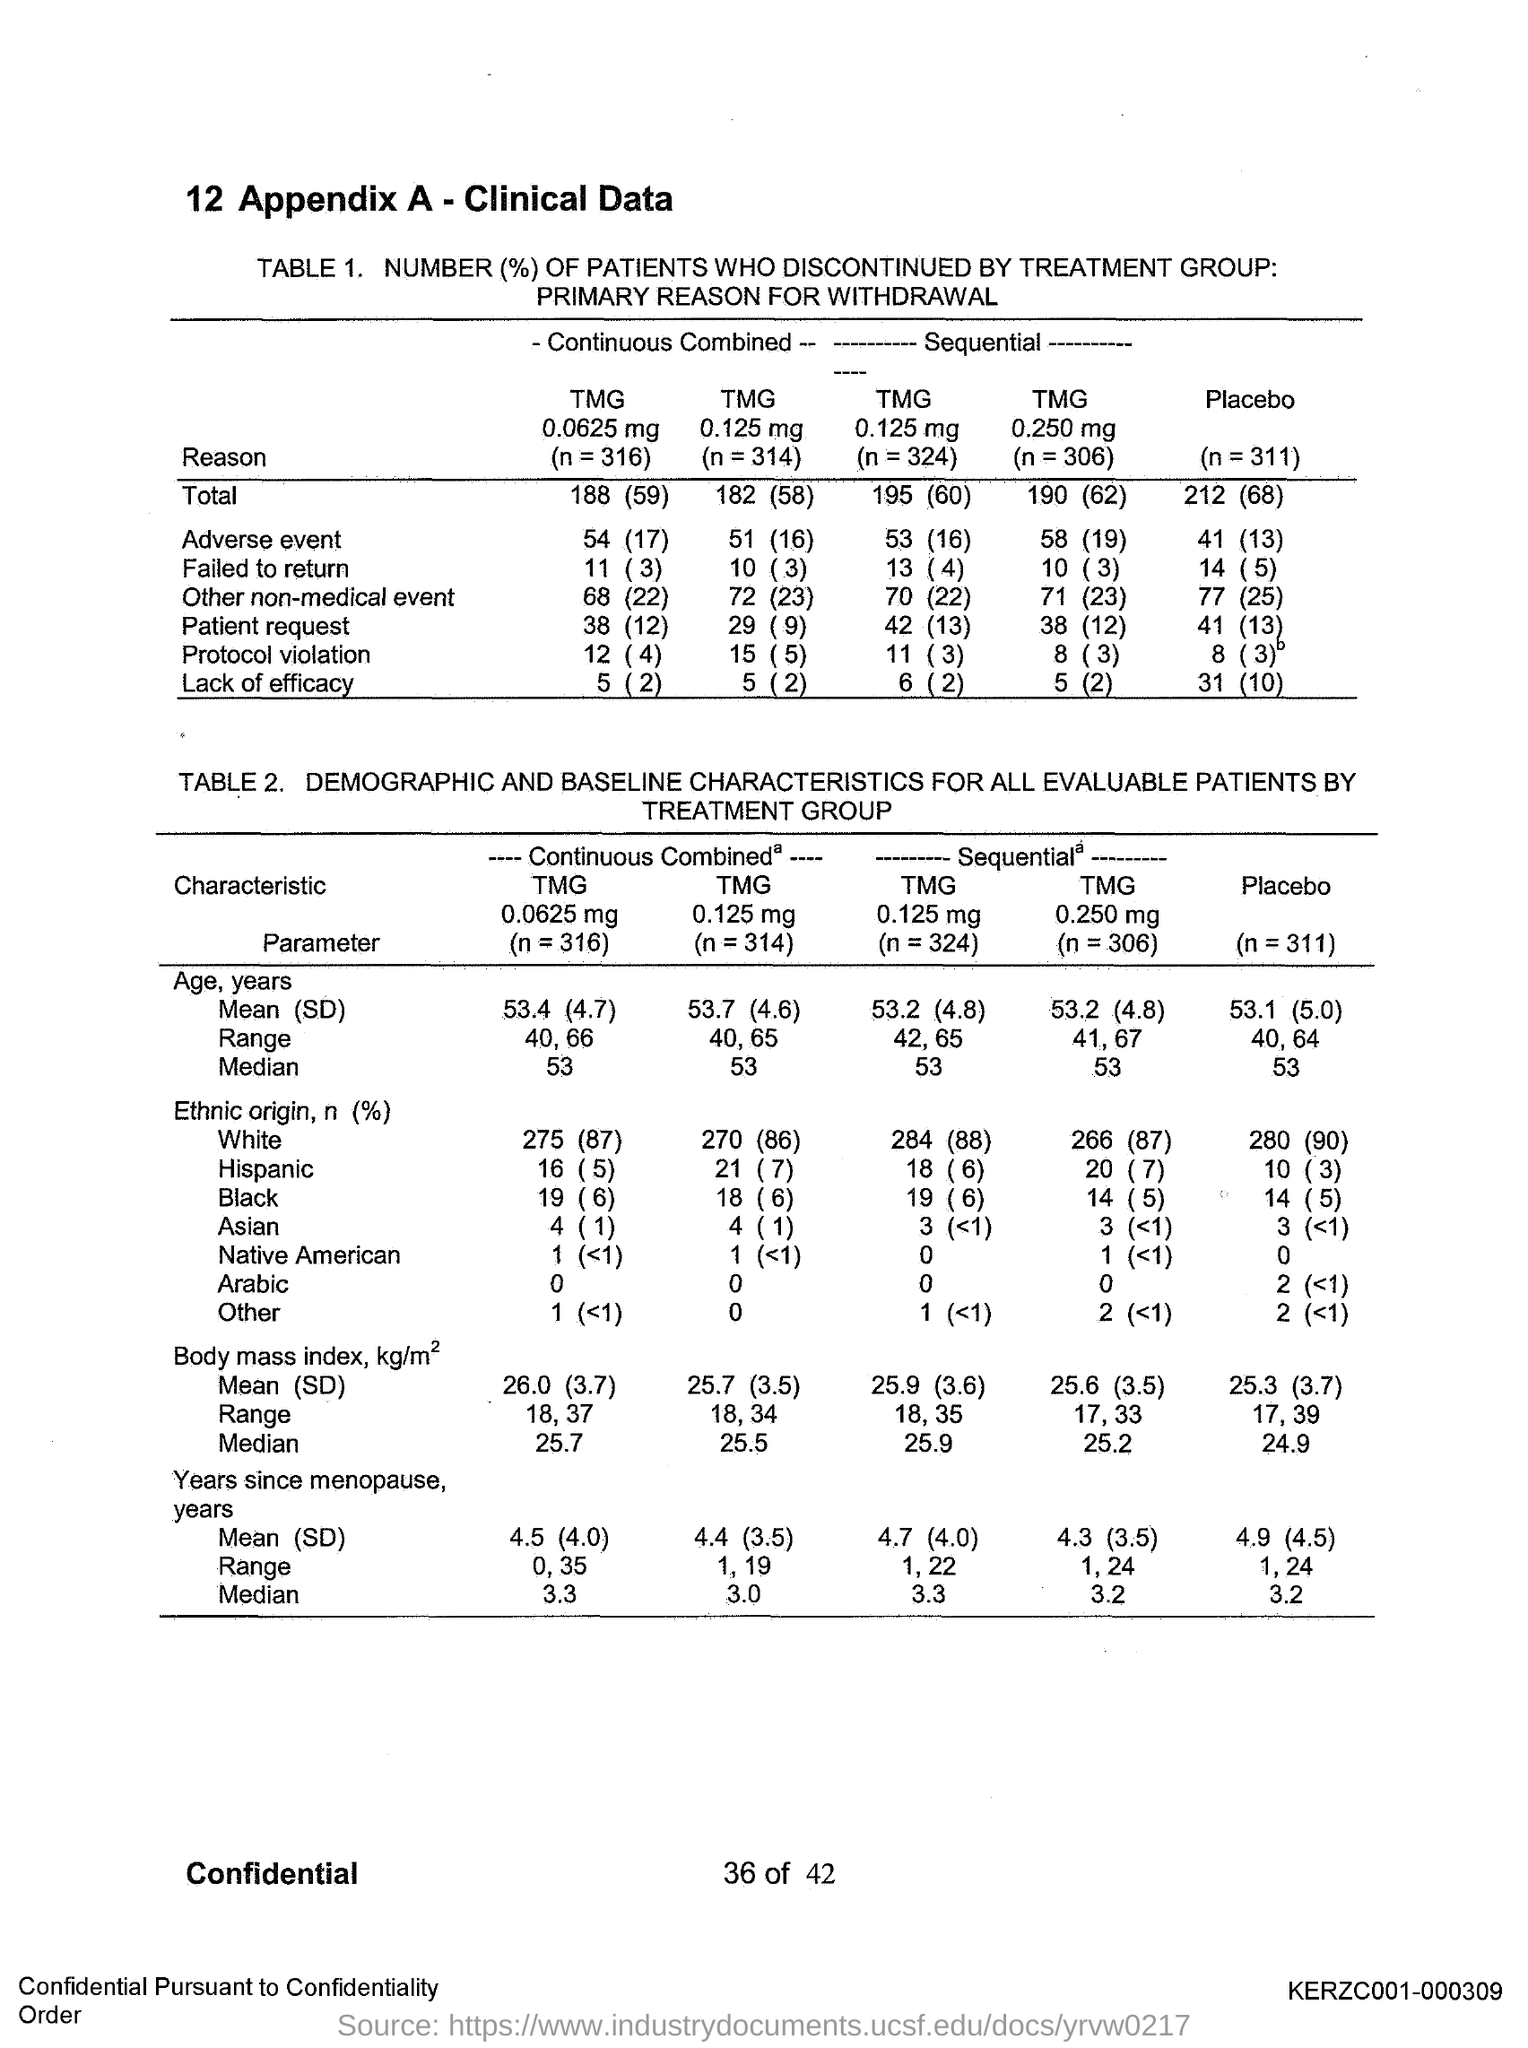Specify some key components in this picture. The value of n in the placebo effect experiment is 311. 